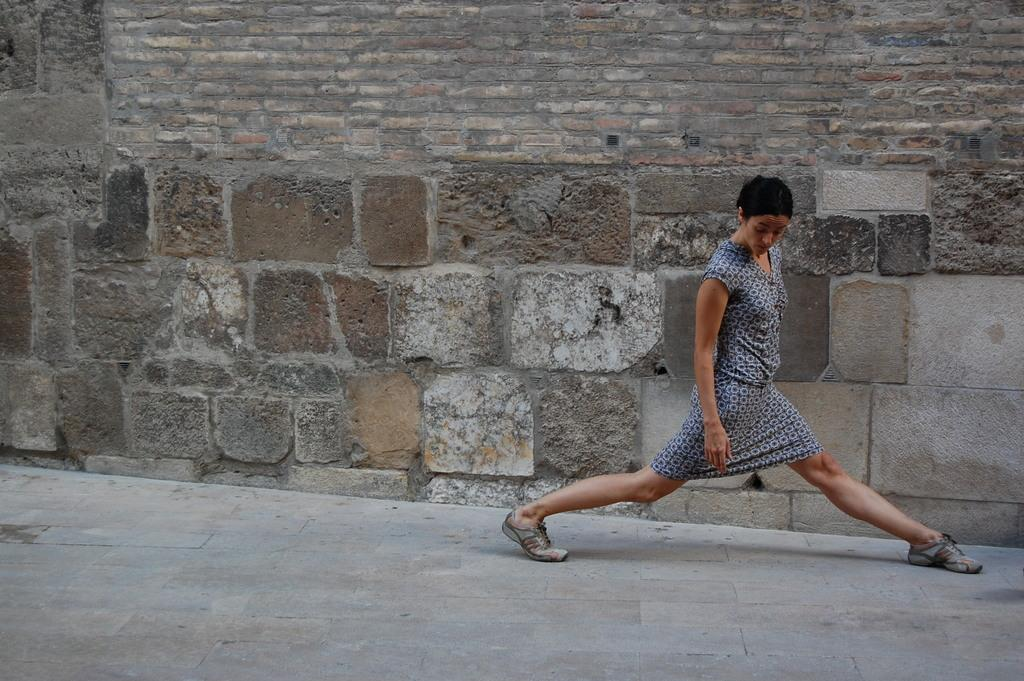What is the main subject of the image? There is a person standing in the image. What is the person wearing? The person is wearing a gray dress. What can be seen in the background of the image? There is a wall in the background of the image. How many boys are riding in the carriage in the image? There is no carriage or boys present in the image; it features a person standing in front of a wall. 